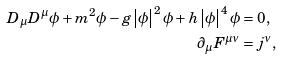<formula> <loc_0><loc_0><loc_500><loc_500>D _ { \mu } D ^ { \mu } \phi + m ^ { 2 } \phi - g \left | \phi \right | ^ { 2 } \phi + h \left | \phi \right | ^ { 4 } \phi & = 0 , \\ \partial _ { \mu } F ^ { \mu \nu } & = j ^ { \nu } ,</formula> 